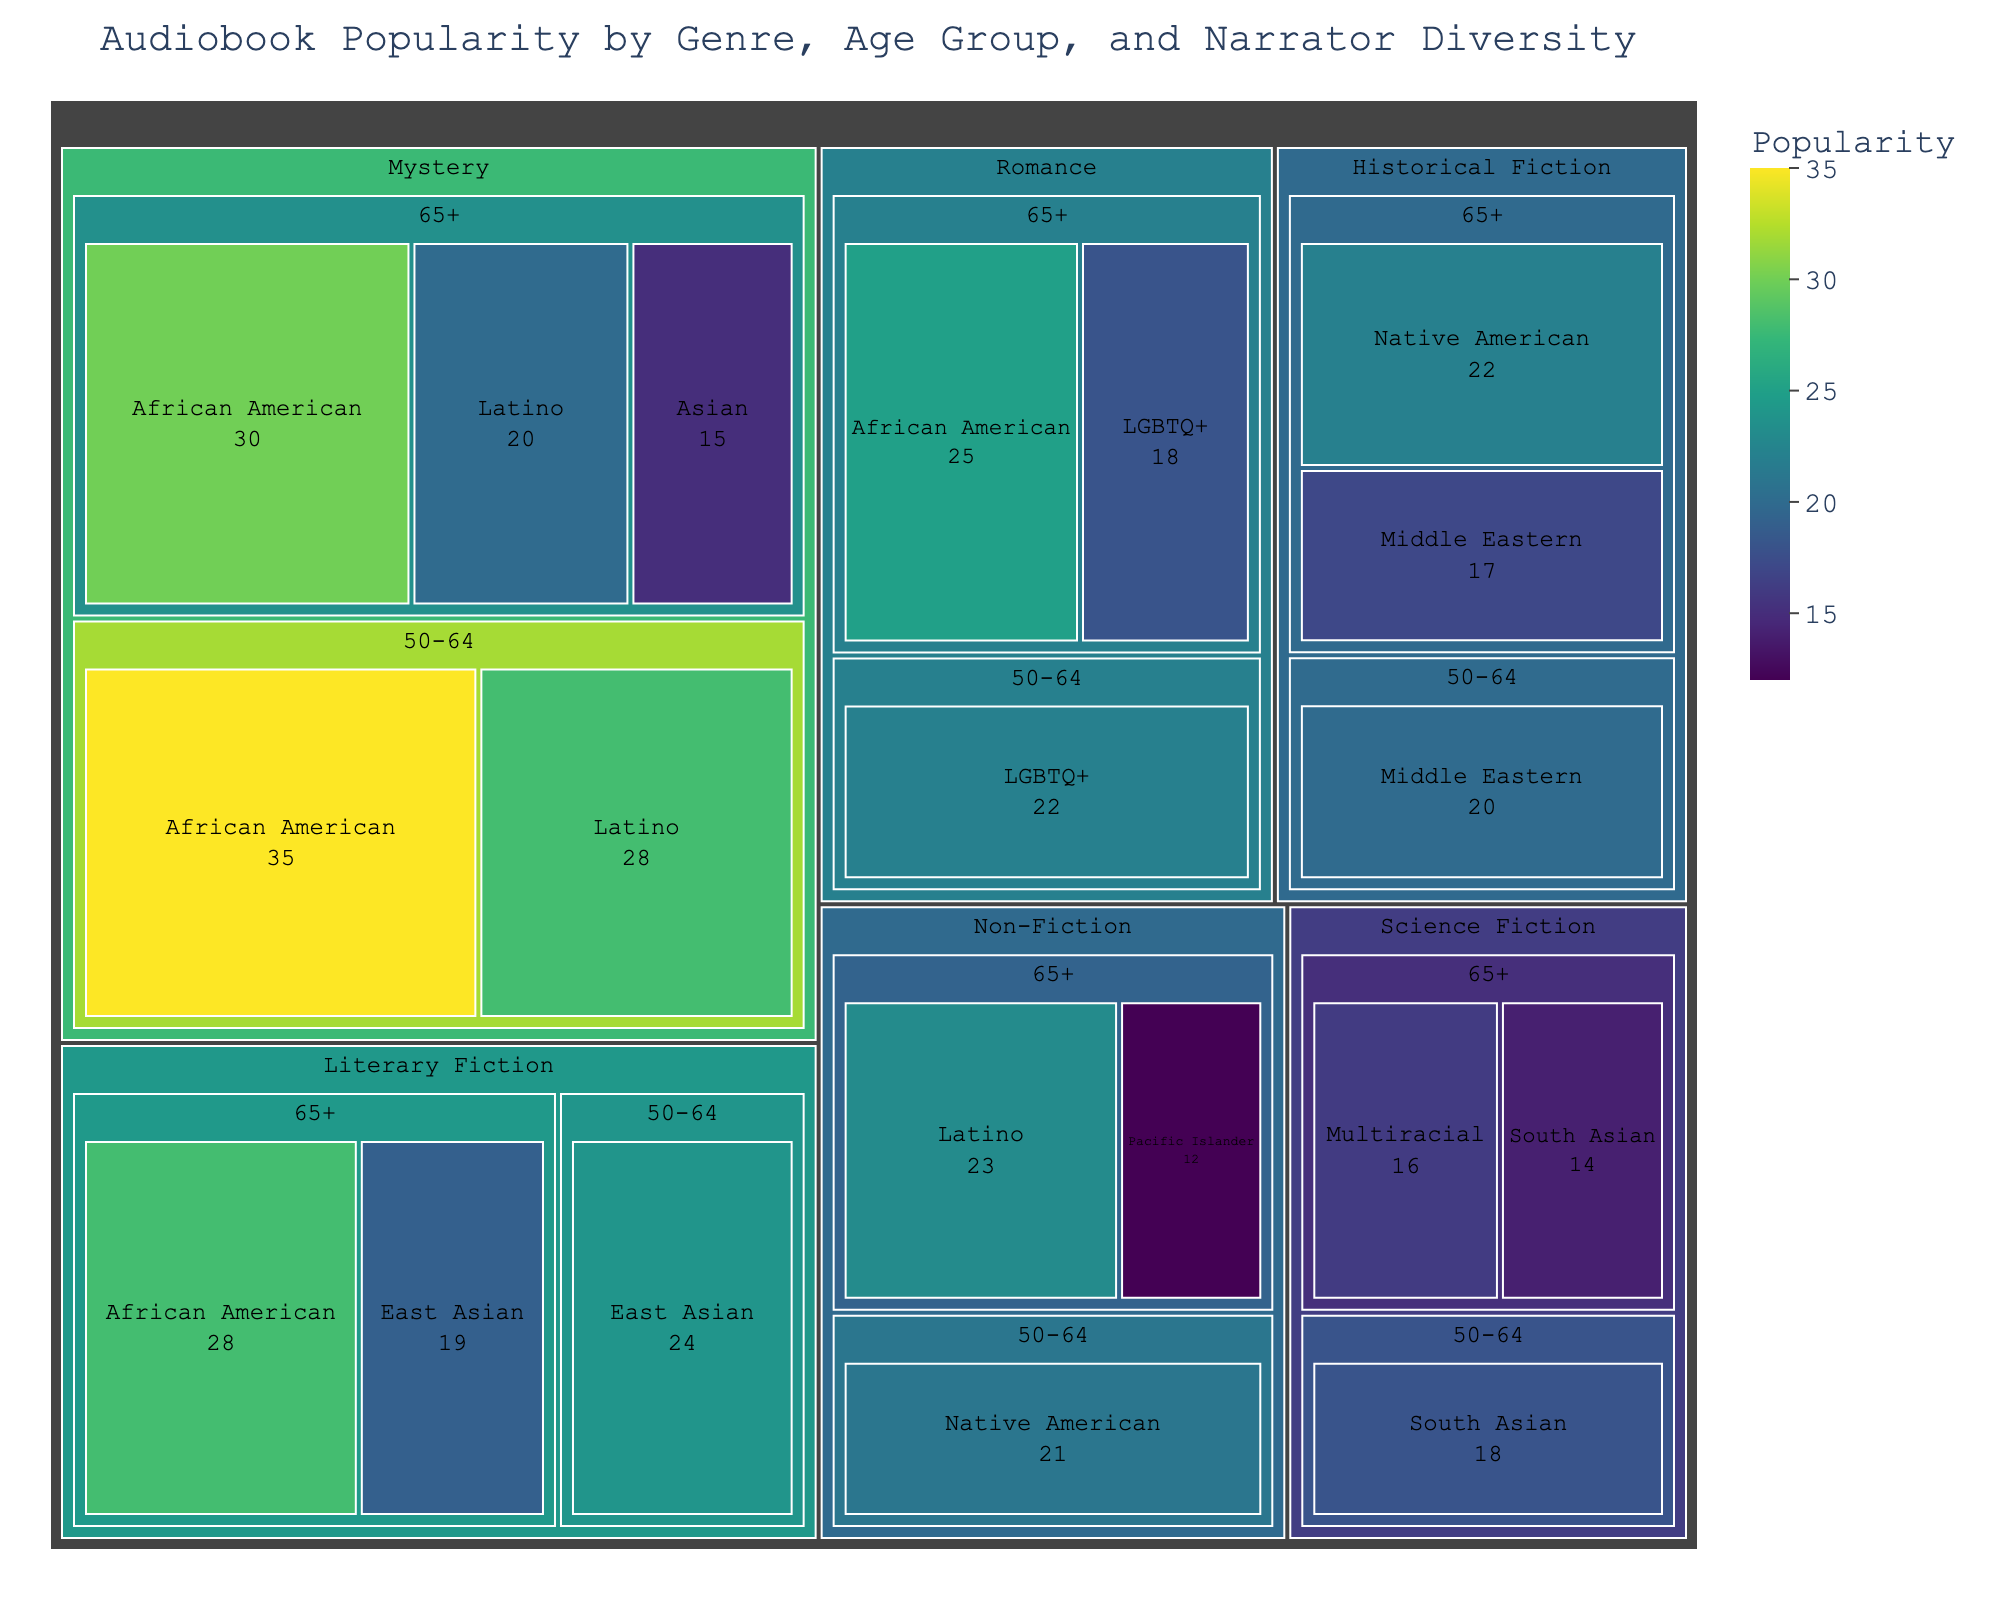What genre in the 65+ age group has the highest audiobook popularity with African American narrators? Look for the "65+" age group and find the genre with African American narrators. Check their popularity values and identify the highest one.
Answer: Mystery Which age group shows the highest popularity for Literary Fiction narrated by East Asian individuals? Locate Literary Fiction and examine the popularity values for East Asian narrators across the age groups. Compare to find the highest value.
Answer: 50-64 What is the combined popularity of all Non-Fiction audiobooks for the 65+ age group? Sum the popularity values of Non-Fiction for the 65+ age group across all narrator diversity categories. Compute the total.
Answer: 35 (23 + 12) How does the popularity of Romance audiobooks with African American narrators compare between the 65+ and 50-64 age groups? Check the popularity values for African American narrators in the Romance genre for both age groups and compare them.
Answer: Higher for 50-64 For Mystery audiobooks, which group (50-64 or 65+) has the most popularity with Latino narrators? Identify the popularity values for Latino narrators in Mystery for both age groups and determine which group has a higher value.
Answer: 50-64 Which genre with Native American narrators has higher popularity in the 65+ group – Historical Fiction or Non-Fiction? Look at the popularity values of Historical Fiction and Non-Fiction genres with Native American narrators in the 65+ age group and compare them.
Answer: Historical Fiction What is the average popularity of Science Fiction audiobooks for the 65+ group across all narrator diversity categories? Add the popularity values for Science Fiction in the 65+ group, then divide by the number of categories.
Answer: 15 (14 + 16) / 2 In the 65+ group, which genre with LGBTQ+ narrators has the highest popularity? Find the genres that have LGBTQ+ narrators in the 65+ age group and the respective popularity values. Identify the highest number.
Answer: Romance 